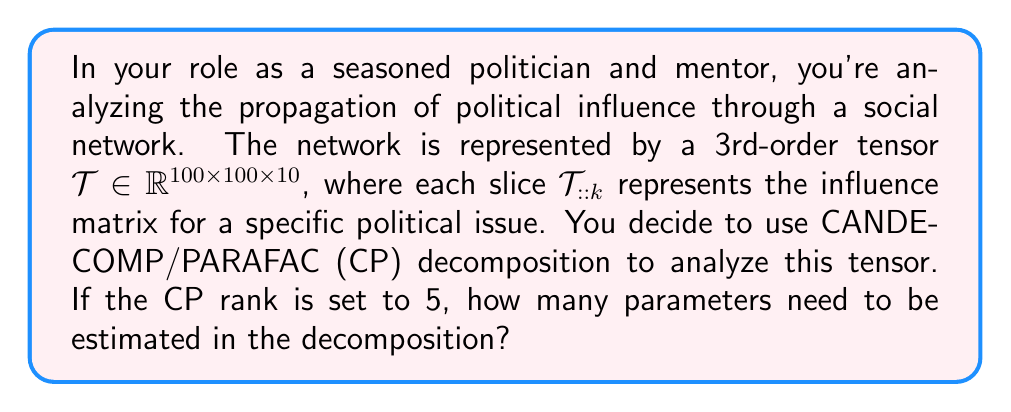Help me with this question. Let's approach this step-by-step:

1) The CP decomposition of a 3rd-order tensor $\mathcal{T} \in \mathbb{R}^{I \times J \times K}$ with rank R is given by:

   $$\mathcal{T} \approx \sum_{r=1}^R a_r \circ b_r \circ c_r$$

   where $\circ$ denotes the outer product, and $a_r \in \mathbb{R}^I$, $b_r \in \mathbb{R}^J$, and $c_r \in \mathbb{R}^K$.

2) In this case, we have:
   - $I = 100$ (first dimension of the tensor)
   - $J = 100$ (second dimension of the tensor)
   - $K = 10$ (third dimension of the tensor)
   - $R = 5$ (CP rank)

3) For each rank-1 component, we need to estimate:
   - 100 parameters for $a_r$
   - 100 parameters for $b_r$
   - 10 parameters for $c_r$

4) Since we have 5 components (R = 5), the total number of parameters is:

   $$5 \times (100 + 100 + 10) = 5 \times 210 = 1050$$

Therefore, we need to estimate 1050 parameters in total for this CP decomposition.
Answer: 1050 parameters 